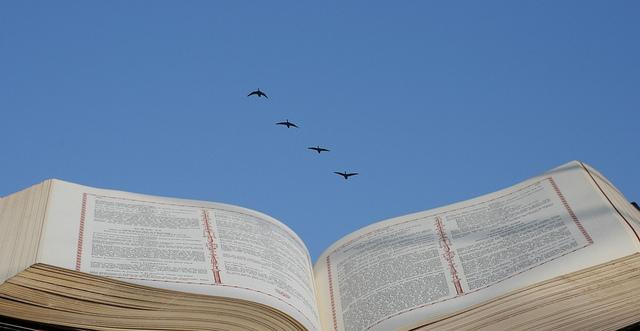Birds seen here are likely doing what? flying 